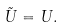<formula> <loc_0><loc_0><loc_500><loc_500>\tilde { U } = U .</formula> 